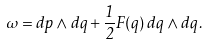Convert formula to latex. <formula><loc_0><loc_0><loc_500><loc_500>\omega = d p \wedge d q + \frac { 1 } { 2 } F ( q ) \, d q \wedge d q \, .</formula> 